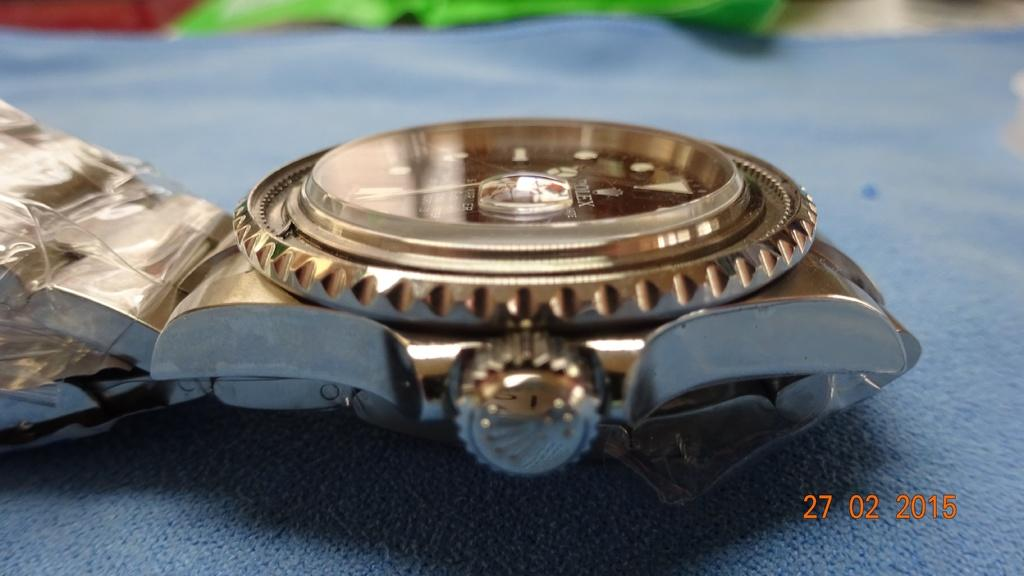<image>
Write a terse but informative summary of the picture. A Rolex brand watch sits on a blue cloth on a table. 